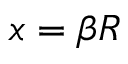<formula> <loc_0><loc_0><loc_500><loc_500>x = \beta R</formula> 